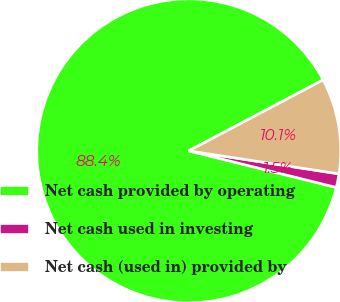Convert chart. <chart><loc_0><loc_0><loc_500><loc_500><pie_chart><fcel>Net cash provided by operating<fcel>Net cash used in investing<fcel>Net cash (used in) provided by<nl><fcel>88.4%<fcel>1.45%<fcel>10.15%<nl></chart> 